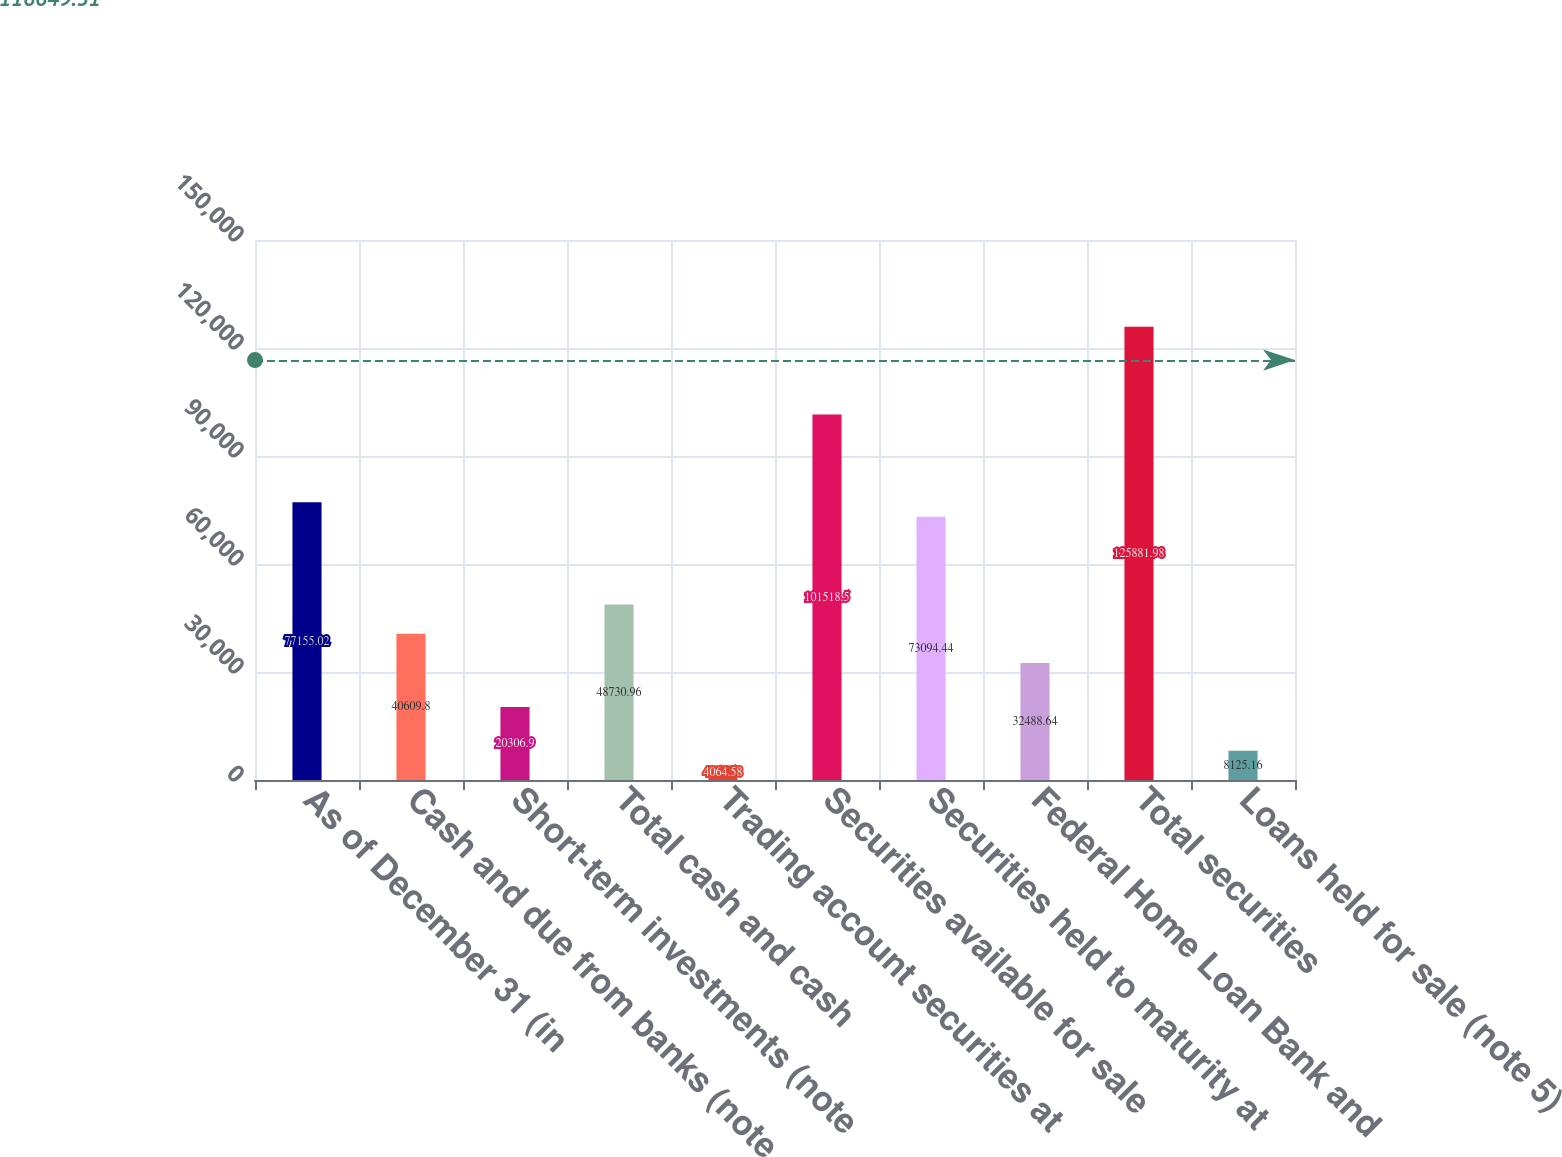Convert chart to OTSL. <chart><loc_0><loc_0><loc_500><loc_500><bar_chart><fcel>As of December 31 (in<fcel>Cash and due from banks (note<fcel>Short-term investments (note<fcel>Total cash and cash<fcel>Trading account securities at<fcel>Securities available for sale<fcel>Securities held to maturity at<fcel>Federal Home Loan Bank and<fcel>Total securities<fcel>Loans held for sale (note 5)<nl><fcel>77155<fcel>40609.8<fcel>20306.9<fcel>48731<fcel>4064.58<fcel>101518<fcel>73094.4<fcel>32488.6<fcel>125882<fcel>8125.16<nl></chart> 